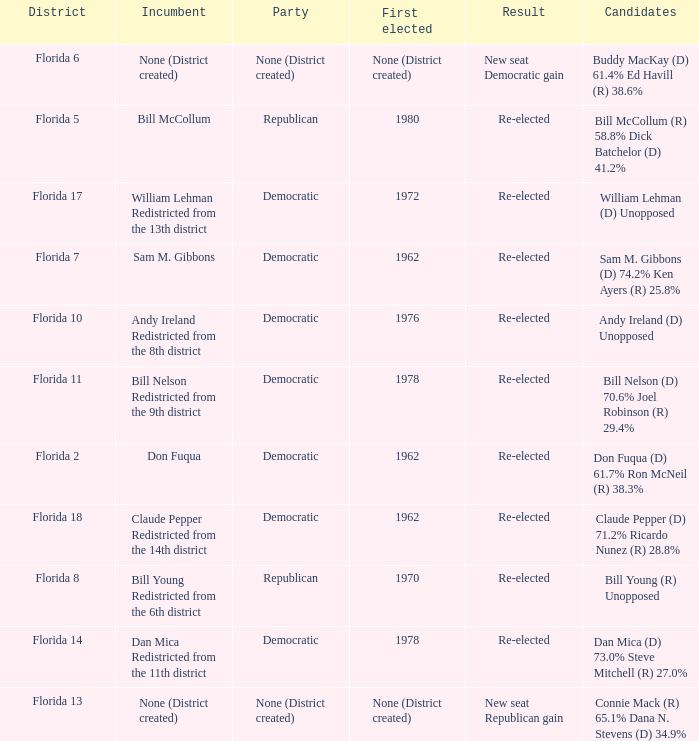 how many result with district being florida 14 1.0. 